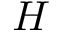<formula> <loc_0><loc_0><loc_500><loc_500>H</formula> 